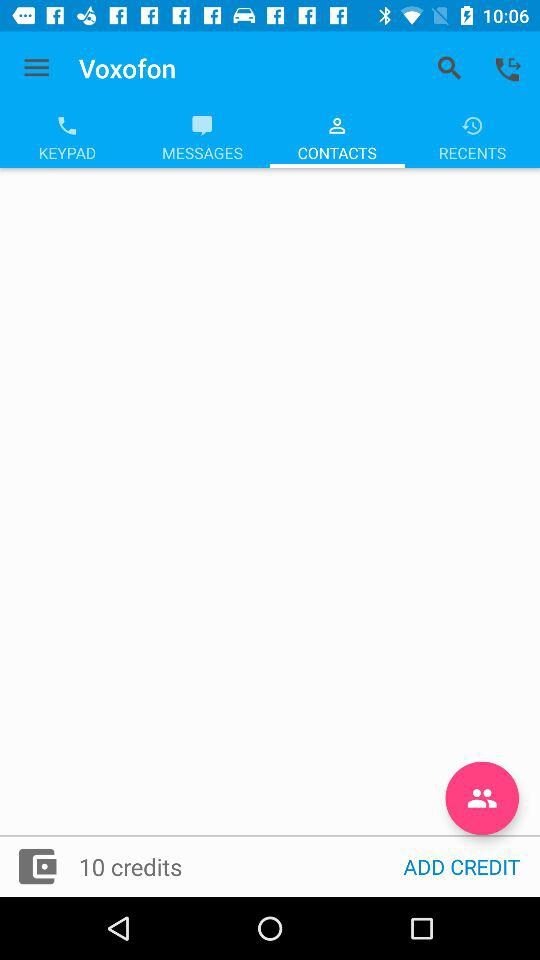What is the number of credits? The number of credits is 10. 